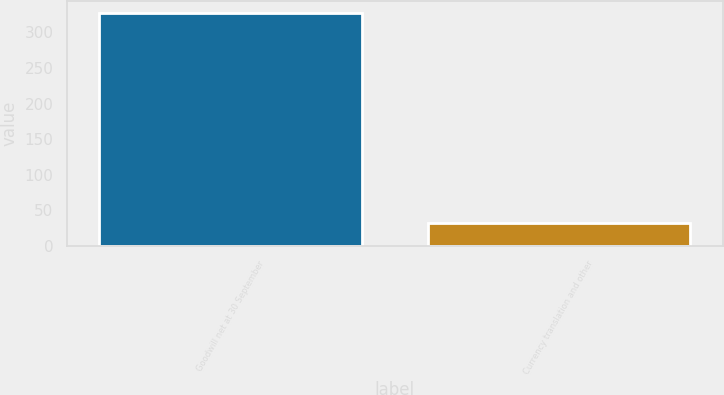<chart> <loc_0><loc_0><loc_500><loc_500><bar_chart><fcel>Goodwill net at 30 September<fcel>Currency translation and other<nl><fcel>327.14<fcel>31.8<nl></chart> 